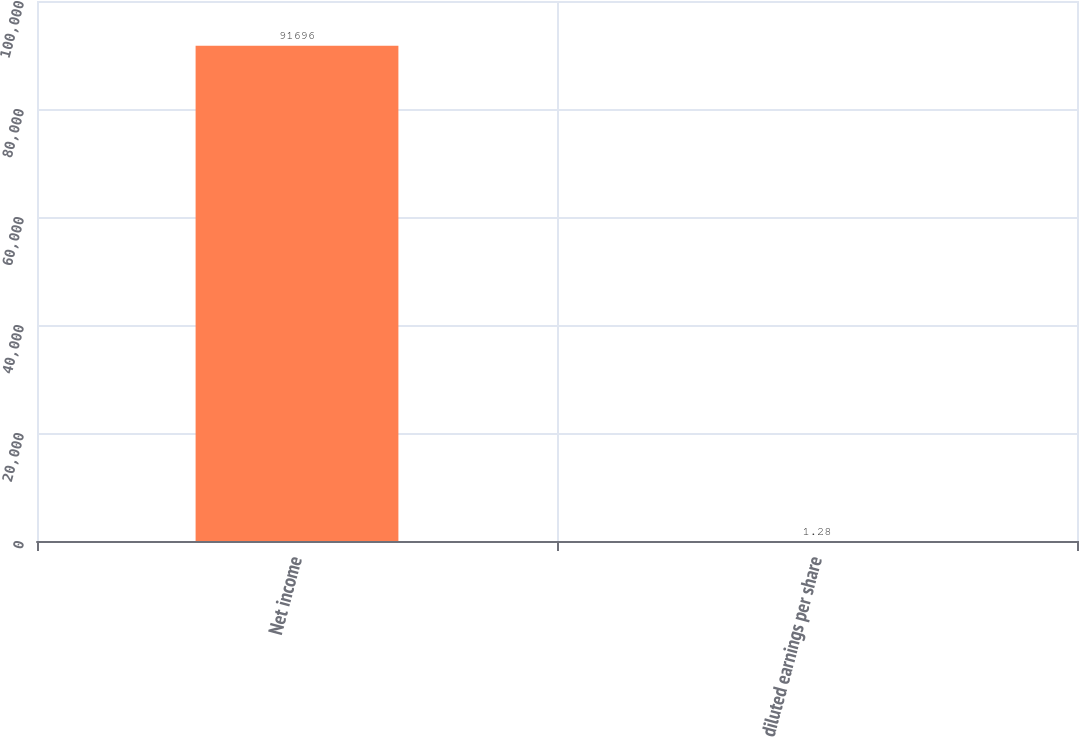<chart> <loc_0><loc_0><loc_500><loc_500><bar_chart><fcel>Net income<fcel>diluted earnings per share<nl><fcel>91696<fcel>1.28<nl></chart> 